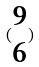<formula> <loc_0><loc_0><loc_500><loc_500>( \begin{matrix} 9 \\ 6 \end{matrix} )</formula> 